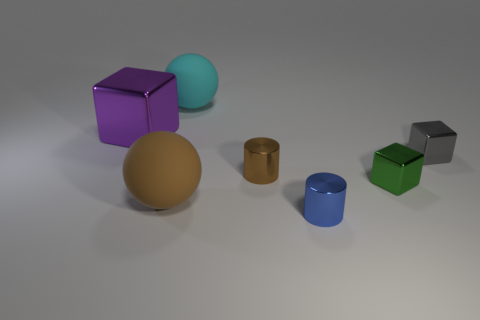The large metal block is what color?
Ensure brevity in your answer.  Purple. What shape is the blue object that is the same material as the tiny green block?
Give a very brief answer. Cylinder. Does the sphere that is in front of the gray metal cube have the same size as the tiny gray metallic block?
Provide a short and direct response. No. What number of things are either cyan matte objects that are behind the small green shiny block or big things in front of the large cyan rubber ball?
Make the answer very short. 3. There is a matte ball left of the cyan matte thing; is it the same color as the large shiny block?
Your response must be concise. No. What number of matte objects are big spheres or big things?
Provide a succinct answer. 2. What is the shape of the tiny brown object?
Give a very brief answer. Cylinder. Are there any other things that have the same material as the blue cylinder?
Offer a terse response. Yes. Are the blue thing and the small gray block made of the same material?
Your answer should be compact. Yes. There is a ball that is on the right side of the big sphere in front of the gray block; is there a tiny object that is to the right of it?
Ensure brevity in your answer.  Yes. 